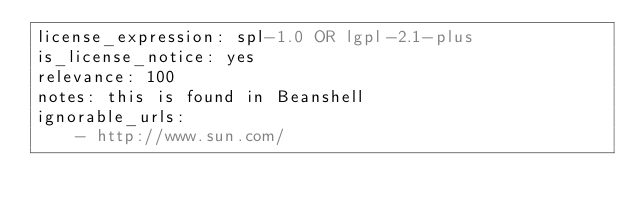Convert code to text. <code><loc_0><loc_0><loc_500><loc_500><_YAML_>license_expression: spl-1.0 OR lgpl-2.1-plus
is_license_notice: yes
relevance: 100
notes: this is found in Beanshell
ignorable_urls:
    - http://www.sun.com/
</code> 